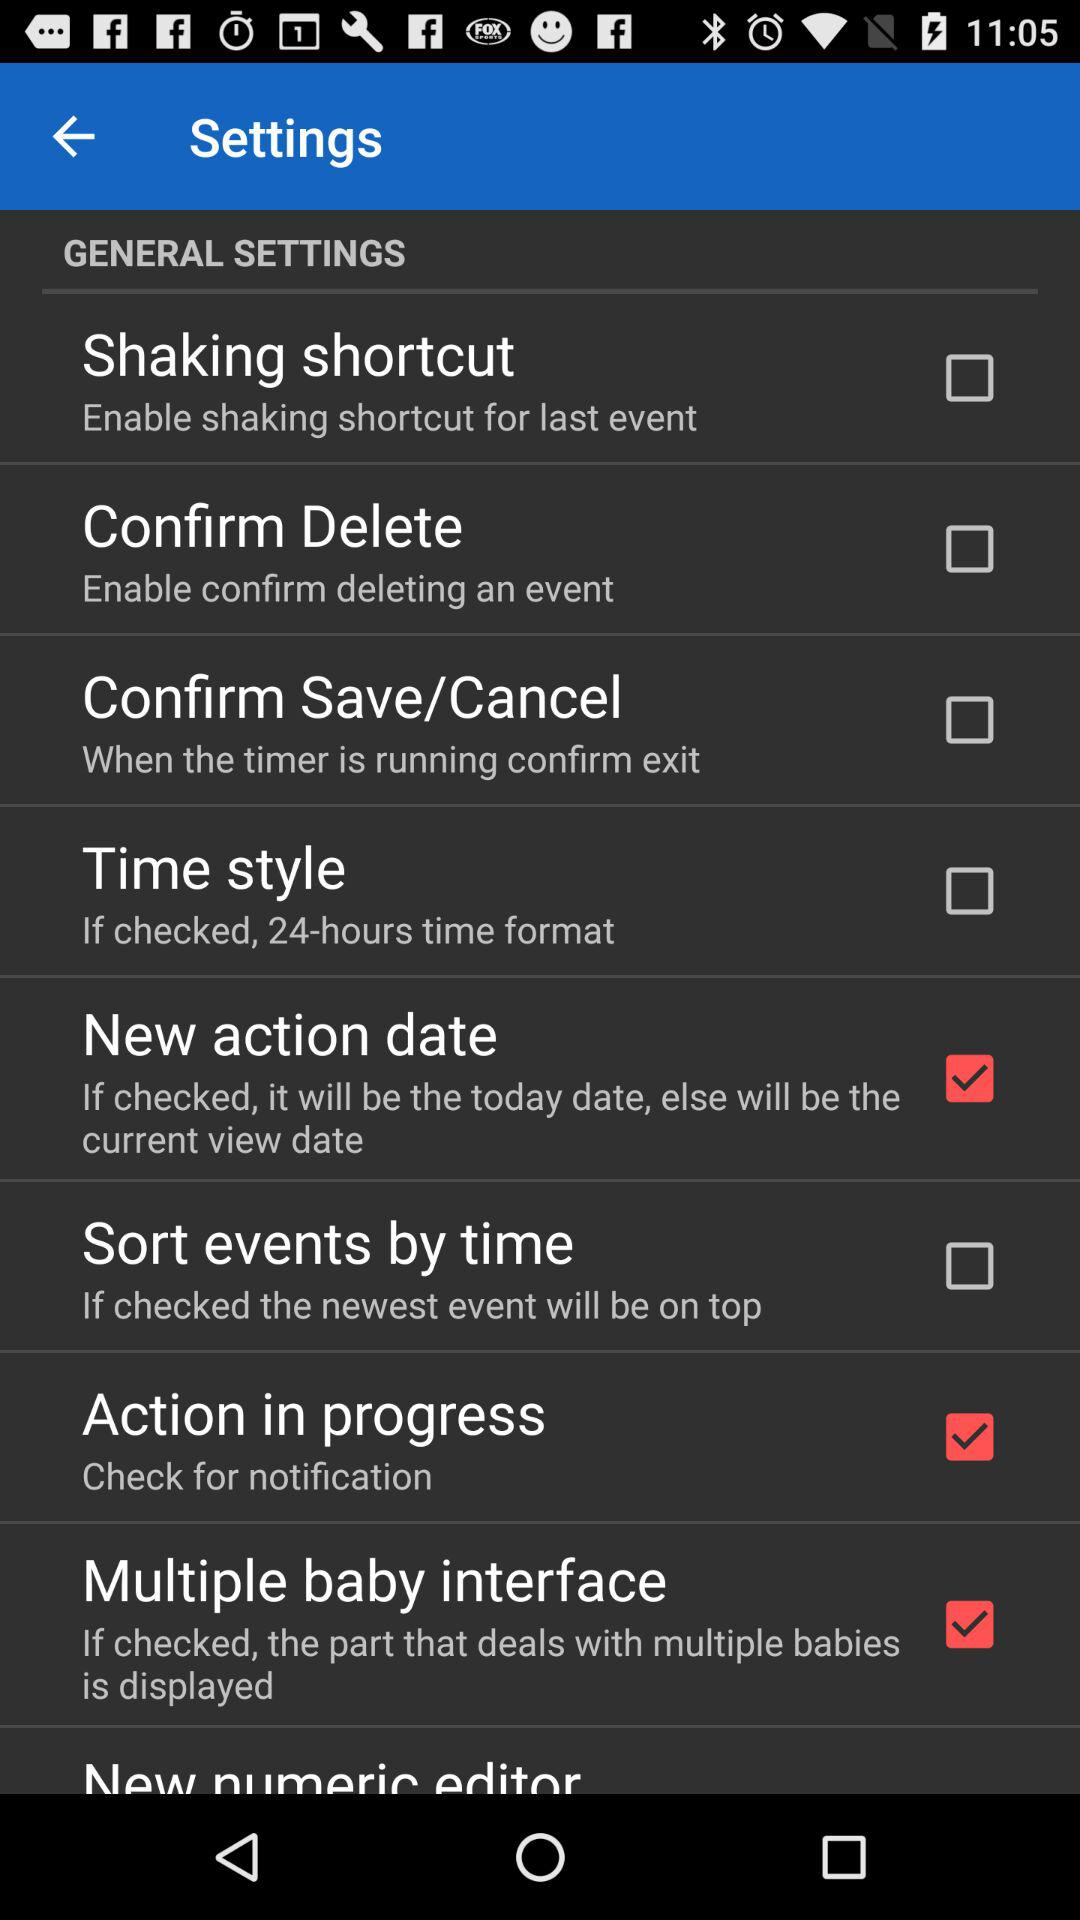What is the status of "New numeric editor"?
When the provided information is insufficient, respond with <no answer>. <no answer> 